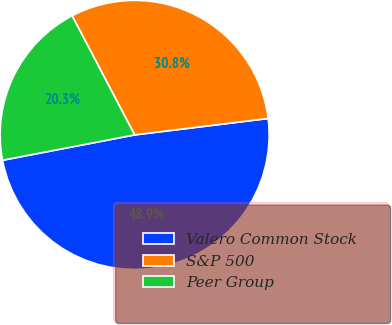Convert chart. <chart><loc_0><loc_0><loc_500><loc_500><pie_chart><fcel>Valero Common Stock<fcel>S&P 500<fcel>Peer Group<nl><fcel>48.93%<fcel>30.75%<fcel>20.32%<nl></chart> 